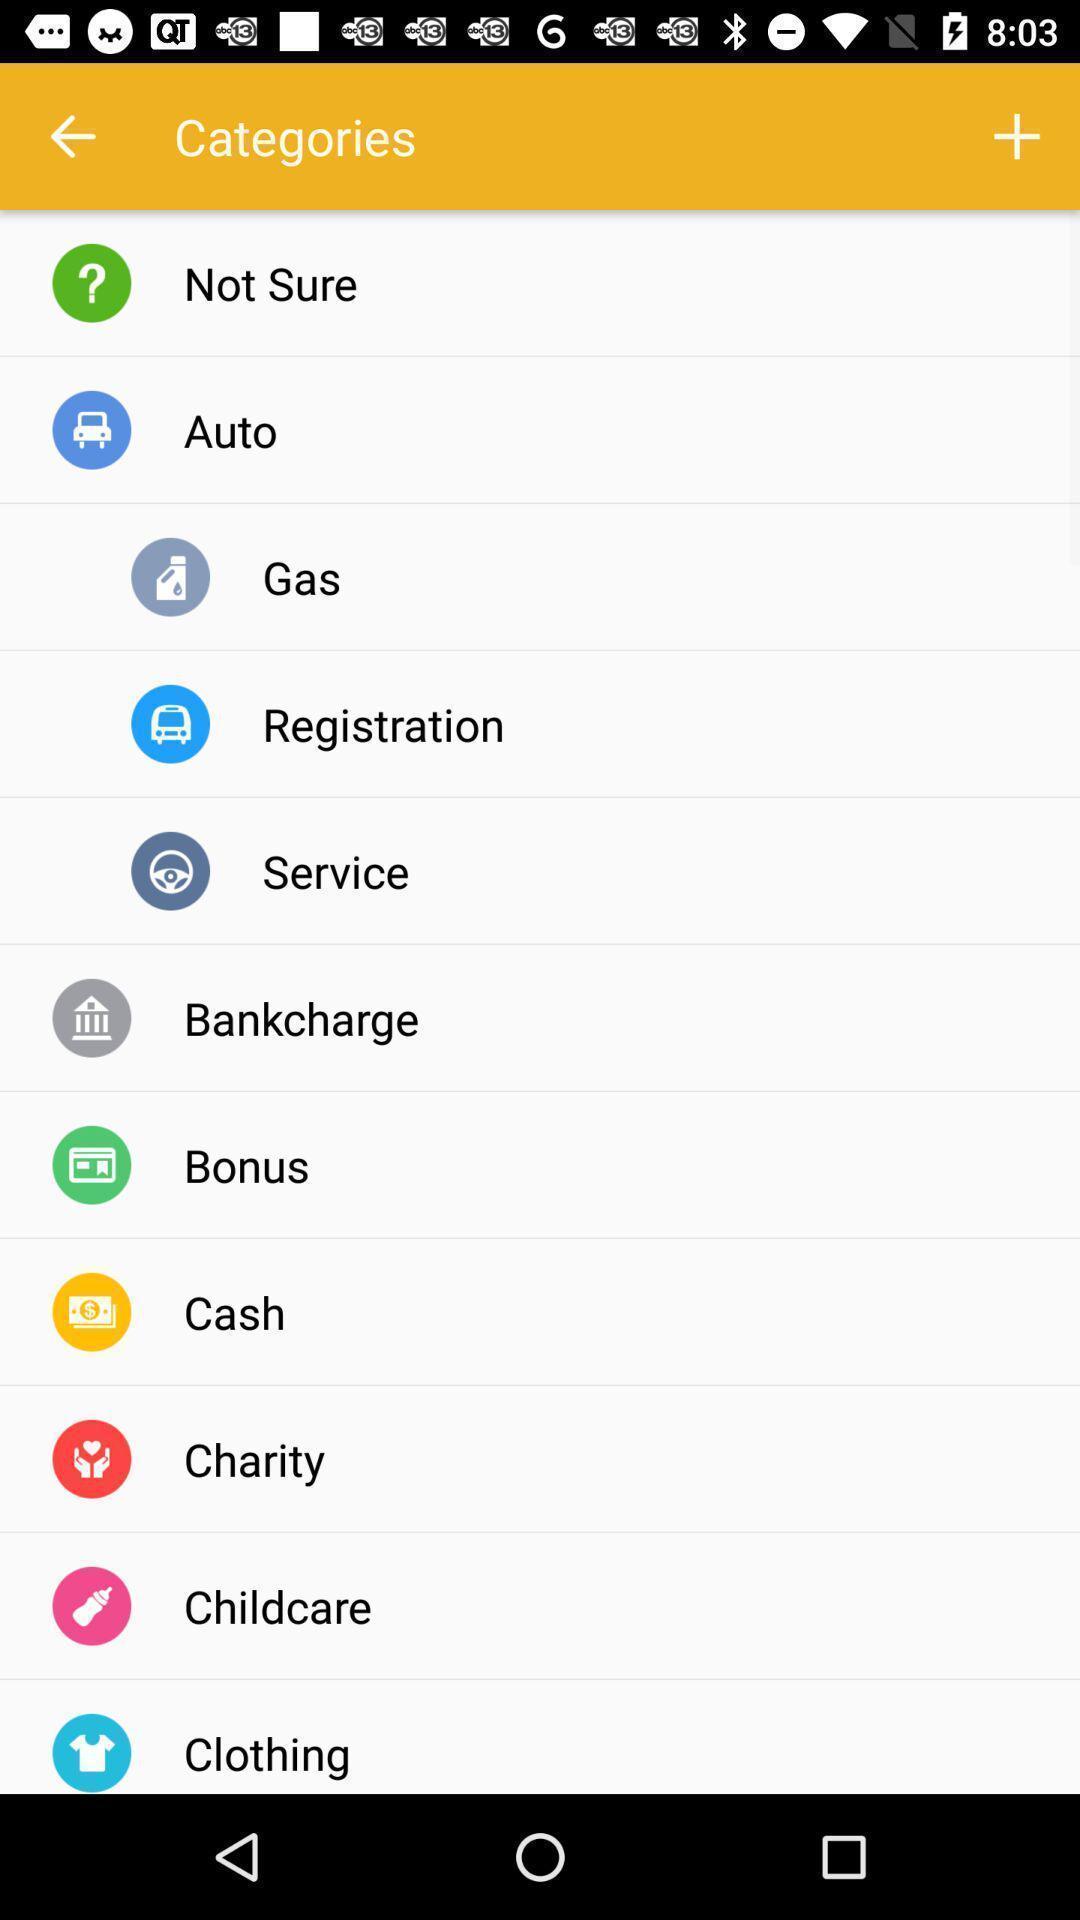What details can you identify in this image? Page showing various categories on app. 